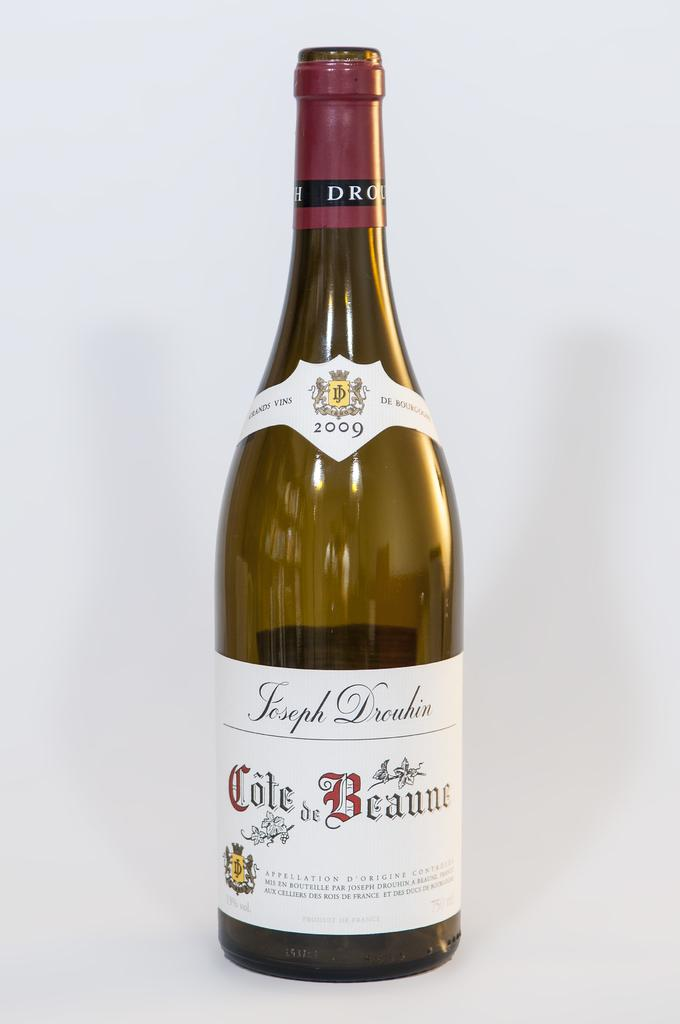<image>
Give a short and clear explanation of the subsequent image. A bottle of 2009 Joseph Drouhin Cote de Beaune wine on a white background. 